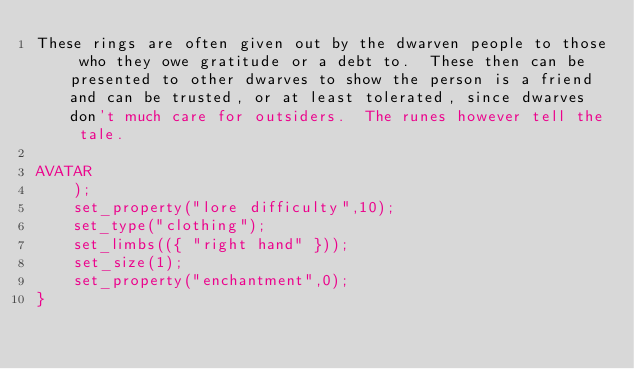Convert code to text. <code><loc_0><loc_0><loc_500><loc_500><_C_>These rings are often given out by the dwarven people to those who they owe gratitude or a debt to.  These then can be presented to other dwarves to show the person is a friend and can be trusted, or at least tolerated, since dwarves don't much care for outsiders.  The runes however tell the tale.

AVATAR
	);
	set_property("lore difficulty",10);
	set_type("clothing");
	set_limbs(({ "right hand" }));
	set_size(1);
	set_property("enchantment",0);
}


</code> 